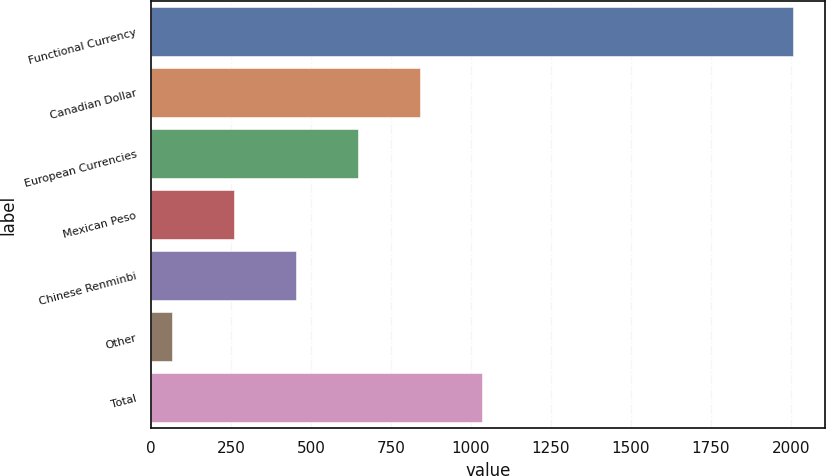<chart> <loc_0><loc_0><loc_500><loc_500><bar_chart><fcel>Functional Currency<fcel>Canadian Dollar<fcel>European Currencies<fcel>Mexican Peso<fcel>Chinese Renminbi<fcel>Other<fcel>Total<nl><fcel>2006<fcel>841.94<fcel>647.93<fcel>259.91<fcel>453.92<fcel>65.9<fcel>1035.95<nl></chart> 